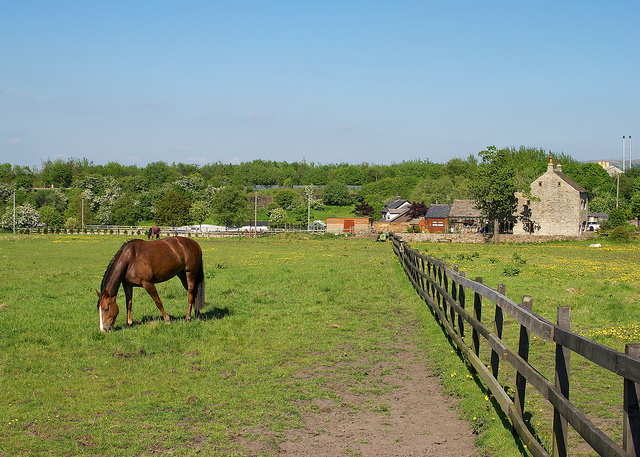Why is the fencing important in this scenario? The fencing shown in the image plays a crucial role by securely enclosing the space where the horse is grazing. It serves to keep the horse within the confines of the farm, preventing it from straying into possibly dangerous areas or wandering onto roads. Additionally, the specific type of sturdy wooden fencing observed here might also deter predators and ensure the horse has a safe environment to roam and graze freely. This containment not only helps in managing the grazing pattern but also aids in routine checks and healthcare management by ensuring the horse does not escape from the designated area. 